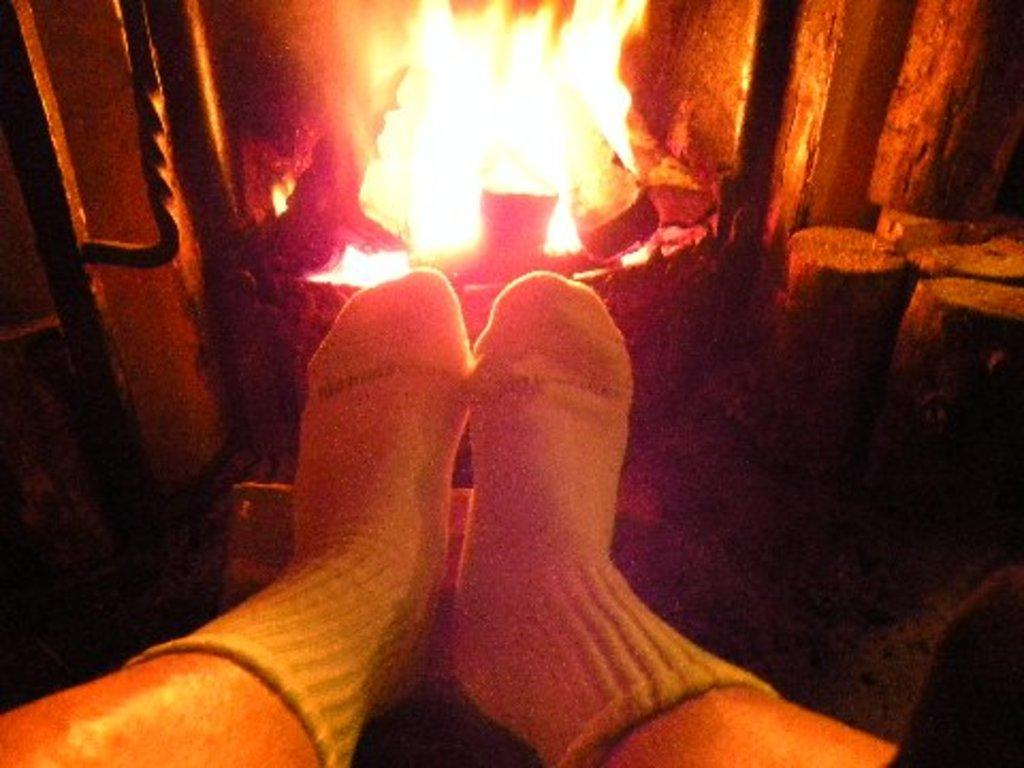What part of a person can be seen in the image? There are legs of a person in the image. Where is the person located in relation to the fire pit? The person is in front of a fire pit. What type of clothing is the person wearing on their feet? The person is wearing socks. How many bikes are visible in the image? There are no bikes present in the image. What type of apples are being used to fuel the fire pit in the image? There are no apples present in the image, and the fire pit is not fueled by apples. 